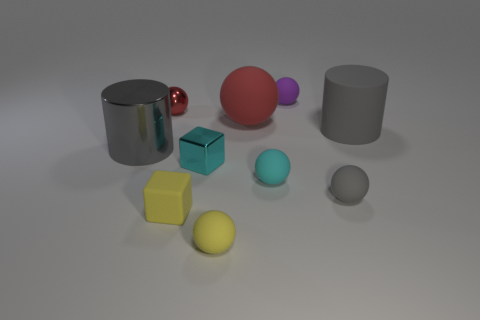What number of things are either small spheres in front of the purple rubber object or cyan objects that are behind the cyan matte object?
Ensure brevity in your answer.  5. Are there any other things that have the same color as the rubber cylinder?
Offer a very short reply. Yes. Is the number of tiny cyan spheres that are in front of the yellow block the same as the number of tiny cyan rubber balls behind the purple thing?
Offer a terse response. Yes. Is the number of yellow blocks that are on the right side of the small shiny cube greater than the number of tiny purple metal cylinders?
Your response must be concise. No. What number of things are spheres on the left side of the tiny purple sphere or big spheres?
Your response must be concise. 4. What number of small purple objects have the same material as the tiny gray object?
Your response must be concise. 1. There is a large metal object that is the same color as the big matte cylinder; what shape is it?
Offer a very short reply. Cylinder. Is there a red thing of the same shape as the cyan rubber thing?
Your answer should be compact. Yes. What is the shape of the cyan metal thing that is the same size as the gray sphere?
Your answer should be very brief. Cube. There is a rubber block; is its color the same as the large rubber object that is to the left of the cyan ball?
Your answer should be compact. No. 